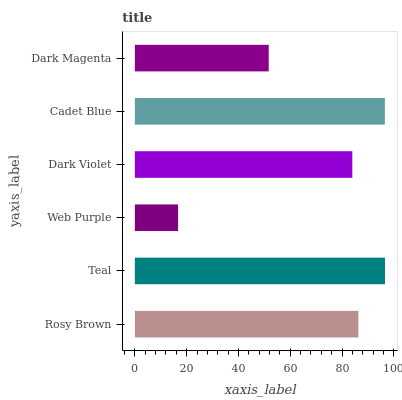Is Web Purple the minimum?
Answer yes or no. Yes. Is Teal the maximum?
Answer yes or no. Yes. Is Teal the minimum?
Answer yes or no. No. Is Web Purple the maximum?
Answer yes or no. No. Is Teal greater than Web Purple?
Answer yes or no. Yes. Is Web Purple less than Teal?
Answer yes or no. Yes. Is Web Purple greater than Teal?
Answer yes or no. No. Is Teal less than Web Purple?
Answer yes or no. No. Is Rosy Brown the high median?
Answer yes or no. Yes. Is Dark Violet the low median?
Answer yes or no. Yes. Is Dark Violet the high median?
Answer yes or no. No. Is Dark Magenta the low median?
Answer yes or no. No. 